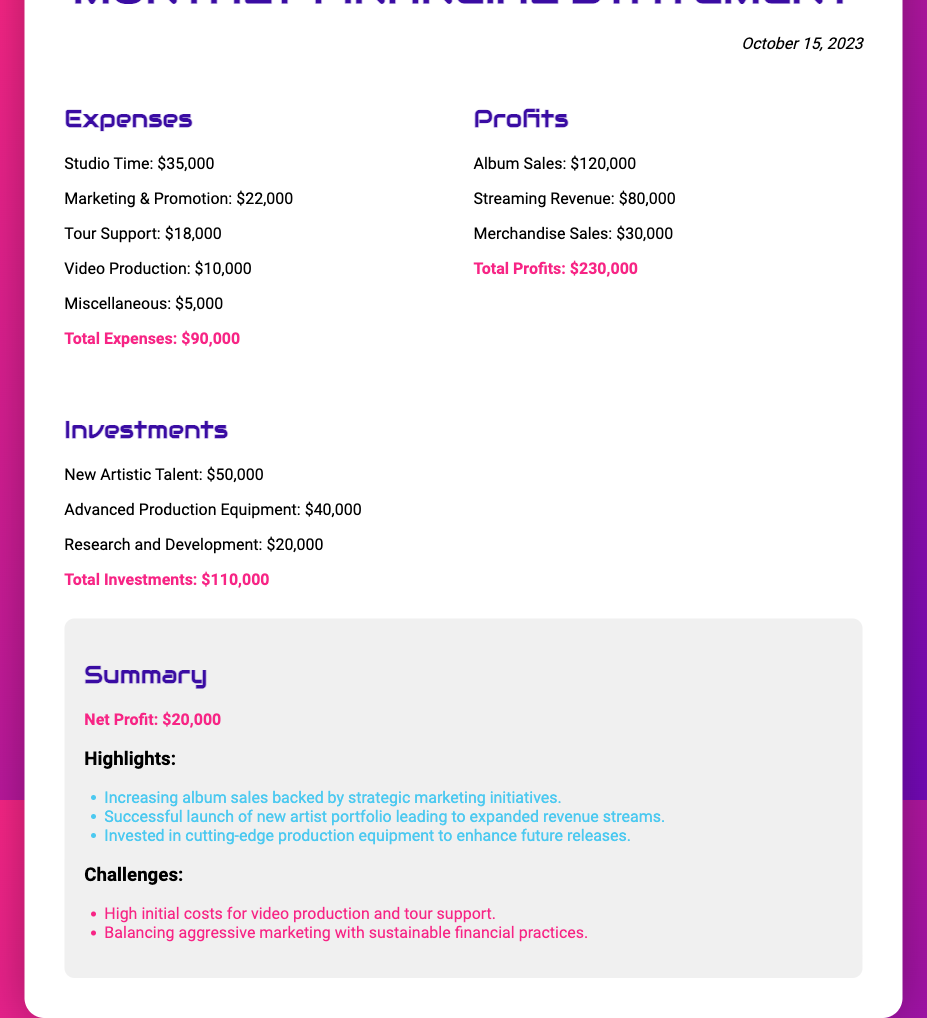what is the total expenses? The total expenses are provided in the document, which sum up to $90,000.
Answer: $90,000 what is the date of the financial statement? The date mentioned in the document is stated at the top, which is October 15, 2023.
Answer: October 15, 2023 who is the recipient of the financial statement? The recipient's name is given in the document as Alexis Masters.
Answer: Alexis Masters what is the net profit? The net profit is highlighted at the end of the summary section, which is $20,000.
Answer: $20,000 how much was invested in new artistic talent? The investment in new artistic talent is listed as $50,000 in the investments section.
Answer: $50,000 what are the total profits? The total profits are calculated from different revenue sources provided in the document, which amount to $230,000.
Answer: $230,000 what is one of the highlights mentioned in the summary? The highlights section includes successful initiatives and is summarized with notable points; one highlight is given as increasing album sales backed by strategic marketing.
Answer: Increasing album sales backed by strategic marketing initiatives what is one of the challenges mentioned? The challenges listed in the summary section mention the high initial costs for video production and tour support as one of the challenges.
Answer: High initial costs for video production and tour support 